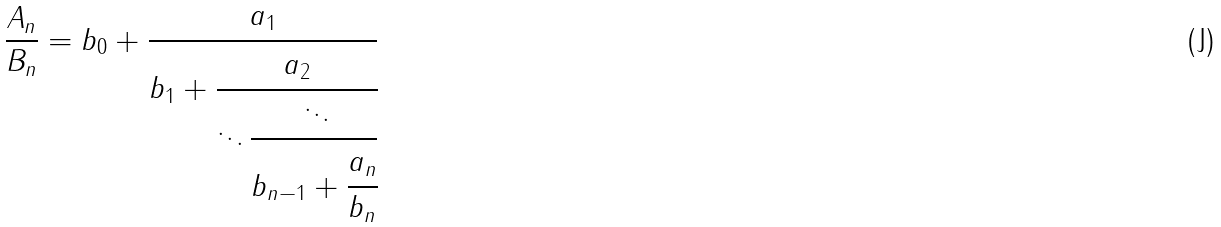<formula> <loc_0><loc_0><loc_500><loc_500>\frac { A _ { n } } { B _ { n } } = b _ { 0 } + \cfrac { a _ { 1 } } { b _ { 1 } + \cfrac { a _ { 2 } } { \ddots \cfrac { \ddots } { b _ { n - 1 } + \cfrac { a _ { n } } { b _ { n } } } } }</formula> 